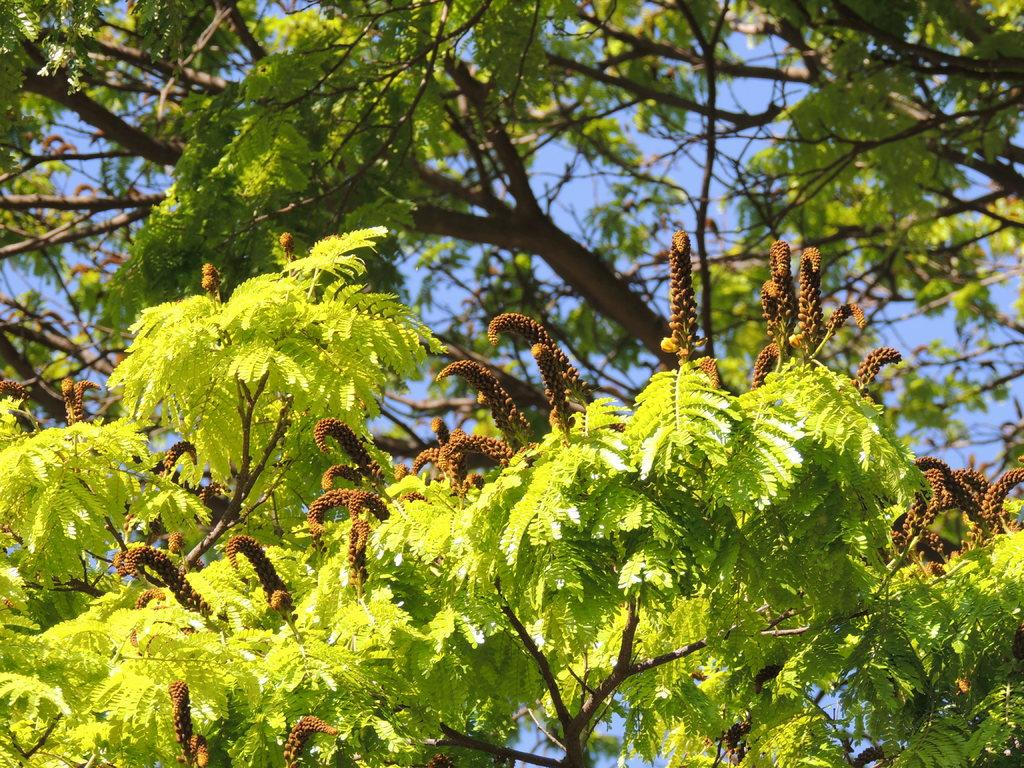What type of vegetation can be seen in the image? There are trees in the image. What part of the natural environment is visible in the image? The sky is visible in the background of the image. What type of pen is being used by the duck in the image? There is no duck or pen present in the image; it only features trees and the sky. 